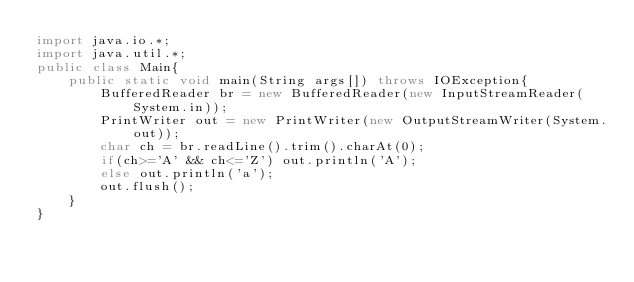<code> <loc_0><loc_0><loc_500><loc_500><_Java_>import java.io.*;
import java.util.*;
public class Main{
    public static void main(String args[]) throws IOException{
        BufferedReader br = new BufferedReader(new InputStreamReader(System.in));
        PrintWriter out = new PrintWriter(new OutputStreamWriter(System.out));
        char ch = br.readLine().trim().charAt(0);
        if(ch>='A' && ch<='Z') out.println('A');
        else out.println('a');
        out.flush();
    }
}</code> 